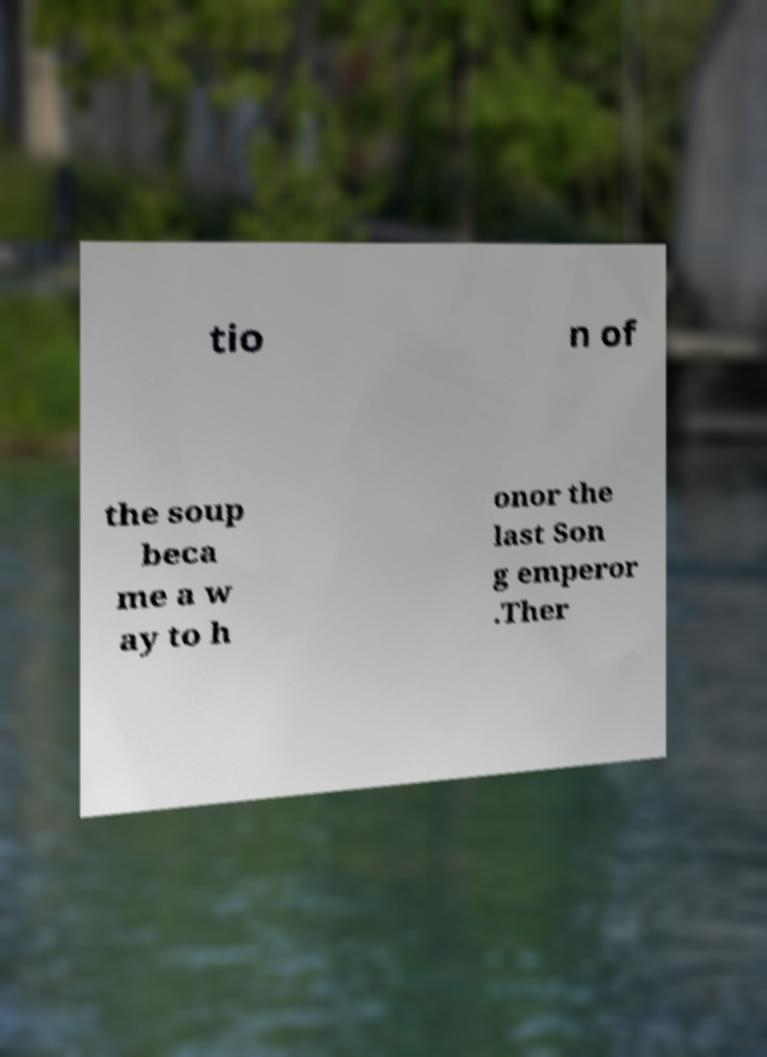Please read and relay the text visible in this image. What does it say? tio n of the soup beca me a w ay to h onor the last Son g emperor .Ther 